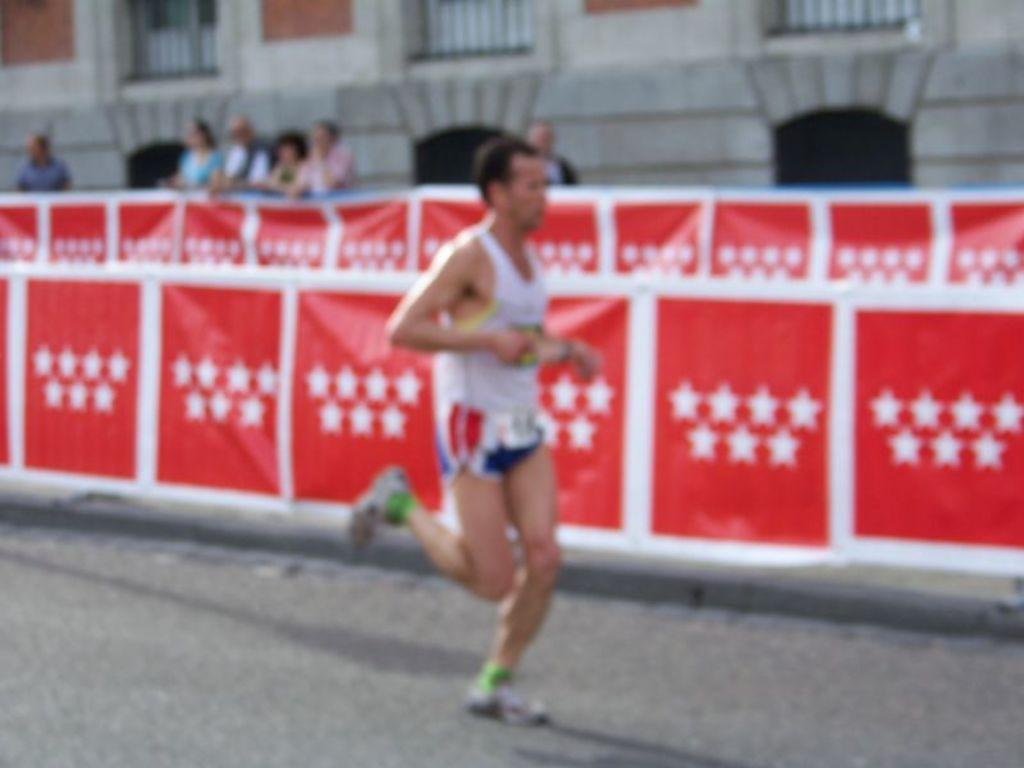What is the main subject of the image? The main subject of the image is a person running on the road. What can be seen behind the person running? There is a banner behind the person. What is happening in the background of the image? There are people standing in front of a building in the background of the image. What type of mitten is the person wearing while running in the image? There is no mitten visible in the image, as the person is running and not wearing any gloves or mittens. 